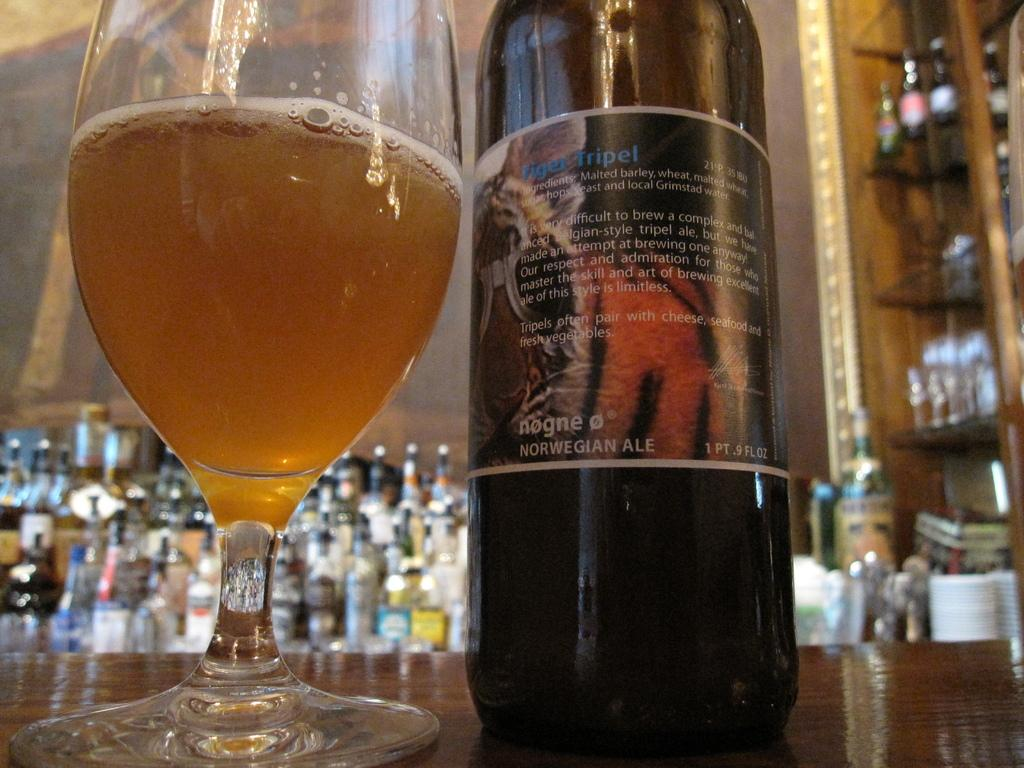Provide a one-sentence caption for the provided image. A bottle of Tiger Tripel is poured into the glass next to it. 